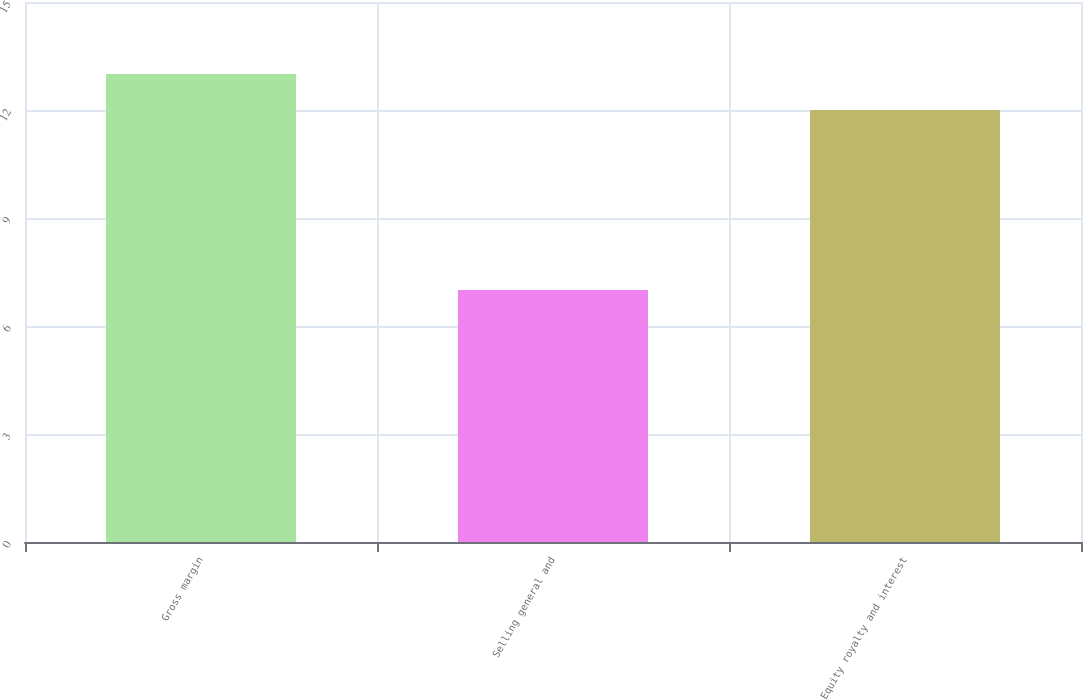Convert chart to OTSL. <chart><loc_0><loc_0><loc_500><loc_500><bar_chart><fcel>Gross margin<fcel>Selling general and<fcel>Equity royalty and interest<nl><fcel>13<fcel>7<fcel>12<nl></chart> 